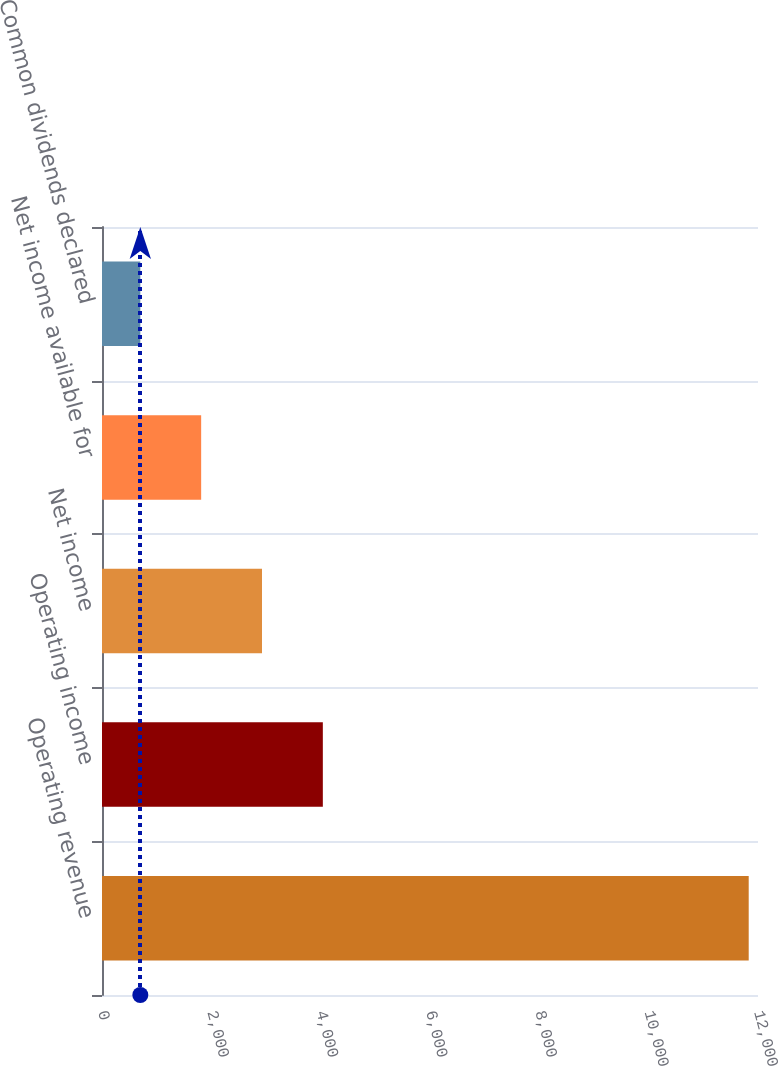Convert chart to OTSL. <chart><loc_0><loc_0><loc_500><loc_500><bar_chart><fcel>Operating revenue<fcel>Operating income<fcel>Net income<fcel>Net income available for<fcel>Common dividends declared<nl><fcel>11830<fcel>4039.7<fcel>2926.8<fcel>1813.9<fcel>701<nl></chart> 